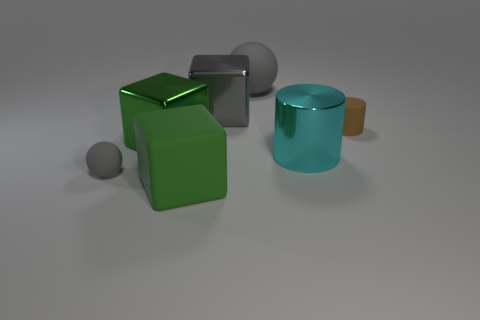Are there any small rubber things that have the same color as the large rubber ball?
Offer a very short reply. Yes. Is the number of large rubber blocks on the right side of the green matte block the same as the number of red metallic cylinders?
Your answer should be compact. Yes. Does the tiny sphere have the same color as the big sphere?
Your answer should be very brief. Yes. There is a rubber object that is right of the green matte object and in front of the gray metal object; what size is it?
Ensure brevity in your answer.  Small. There is a cylinder that is made of the same material as the large gray cube; what color is it?
Make the answer very short. Cyan. How many big green cubes have the same material as the big cyan cylinder?
Offer a very short reply. 1. Are there an equal number of green rubber things in front of the small gray rubber sphere and matte balls in front of the large gray sphere?
Your response must be concise. Yes. Is the shape of the cyan object the same as the large matte thing that is in front of the cyan thing?
Ensure brevity in your answer.  No. There is a big object that is the same color as the matte cube; what is its material?
Your response must be concise. Metal. Is the material of the big sphere the same as the big green thing that is behind the large matte cube?
Your answer should be very brief. No. 